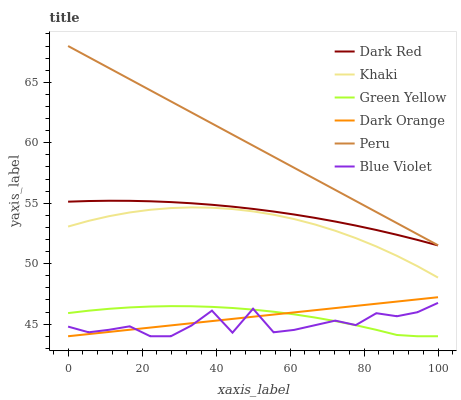Does Blue Violet have the minimum area under the curve?
Answer yes or no. Yes. Does Peru have the maximum area under the curve?
Answer yes or no. Yes. Does Khaki have the minimum area under the curve?
Answer yes or no. No. Does Khaki have the maximum area under the curve?
Answer yes or no. No. Is Peru the smoothest?
Answer yes or no. Yes. Is Blue Violet the roughest?
Answer yes or no. Yes. Is Khaki the smoothest?
Answer yes or no. No. Is Khaki the roughest?
Answer yes or no. No. Does Dark Orange have the lowest value?
Answer yes or no. Yes. Does Khaki have the lowest value?
Answer yes or no. No. Does Peru have the highest value?
Answer yes or no. Yes. Does Khaki have the highest value?
Answer yes or no. No. Is Dark Orange less than Khaki?
Answer yes or no. Yes. Is Peru greater than Blue Violet?
Answer yes or no. Yes. Does Dark Orange intersect Green Yellow?
Answer yes or no. Yes. Is Dark Orange less than Green Yellow?
Answer yes or no. No. Is Dark Orange greater than Green Yellow?
Answer yes or no. No. Does Dark Orange intersect Khaki?
Answer yes or no. No. 